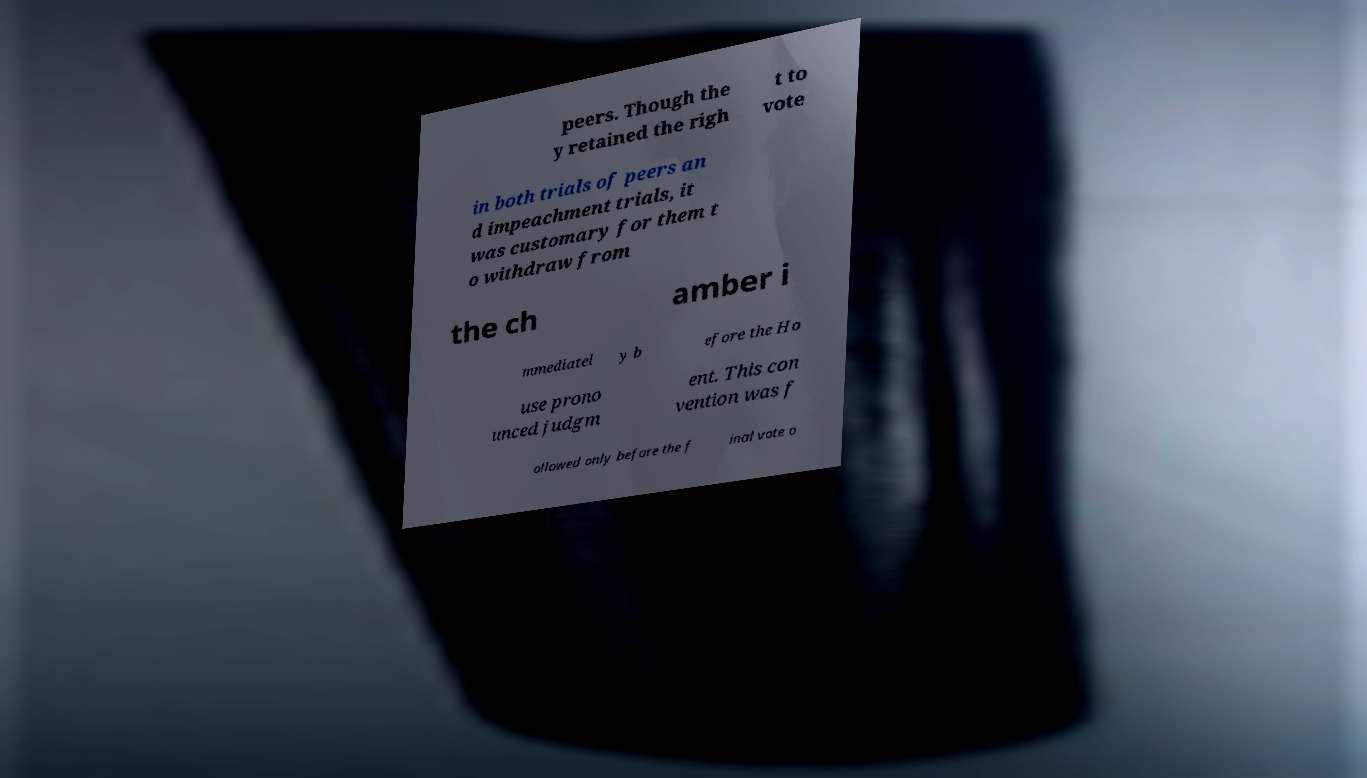Can you read and provide the text displayed in the image?This photo seems to have some interesting text. Can you extract and type it out for me? peers. Though the y retained the righ t to vote in both trials of peers an d impeachment trials, it was customary for them t o withdraw from the ch amber i mmediatel y b efore the Ho use prono unced judgm ent. This con vention was f ollowed only before the f inal vote o 